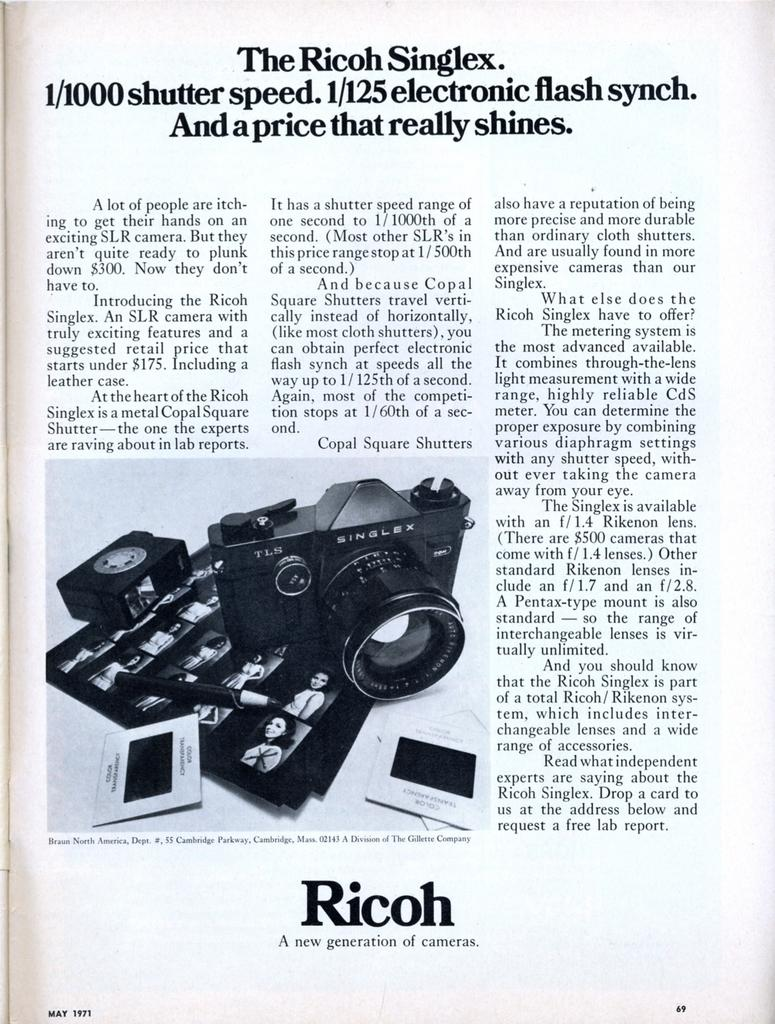What is the main subject of the image? The image is of a page. What can be found on the page? There is writing, a picture of a camera, a picture of a pen, and photos on the page. What is the weather like in the downtown area in the image? There is no information about the weather or a downtown area in the image, as it only shows a page with writing and pictures. 